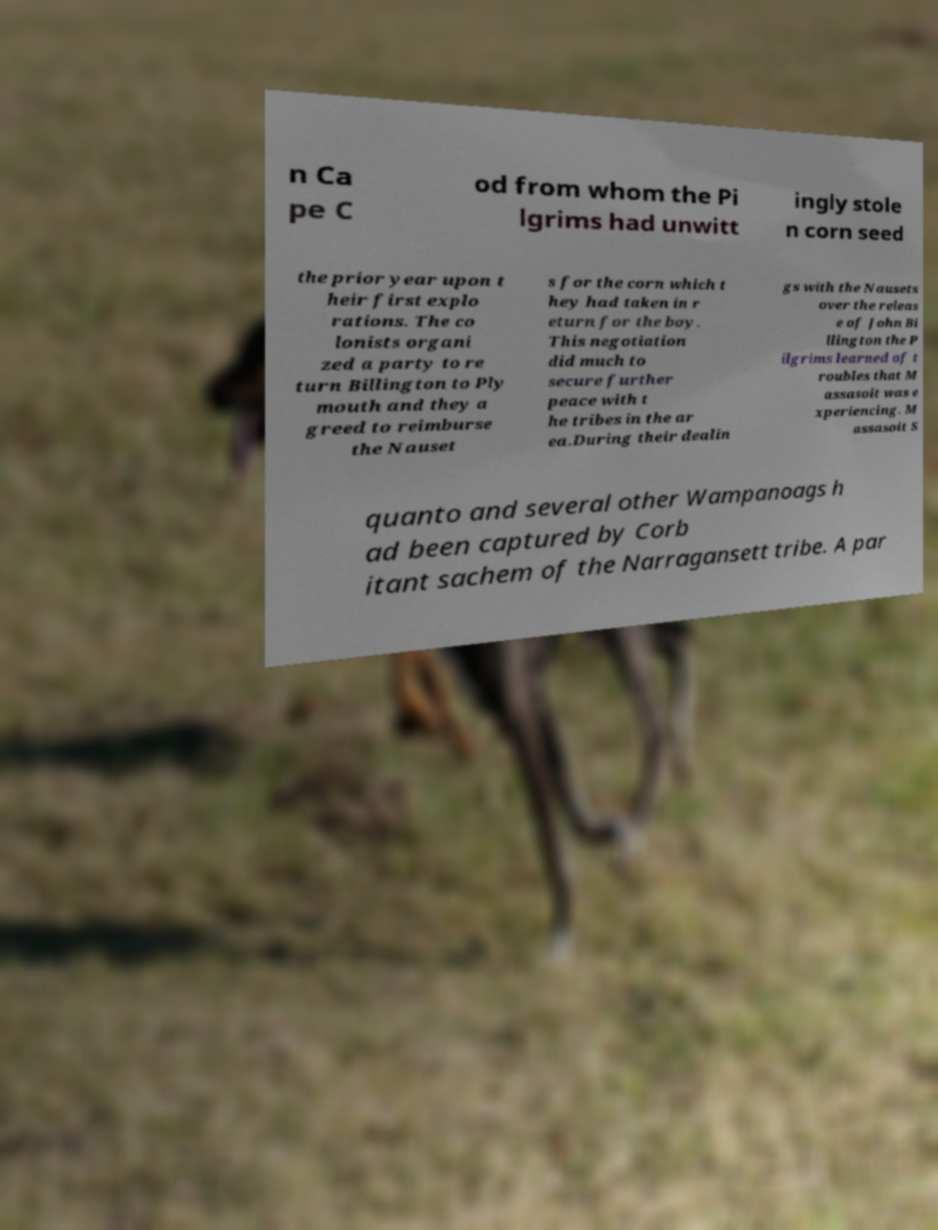For documentation purposes, I need the text within this image transcribed. Could you provide that? n Ca pe C od from whom the Pi lgrims had unwitt ingly stole n corn seed the prior year upon t heir first explo rations. The co lonists organi zed a party to re turn Billington to Ply mouth and they a greed to reimburse the Nauset s for the corn which t hey had taken in r eturn for the boy. This negotiation did much to secure further peace with t he tribes in the ar ea.During their dealin gs with the Nausets over the releas e of John Bi llington the P ilgrims learned of t roubles that M assasoit was e xperiencing. M assasoit S quanto and several other Wampanoags h ad been captured by Corb itant sachem of the Narragansett tribe. A par 